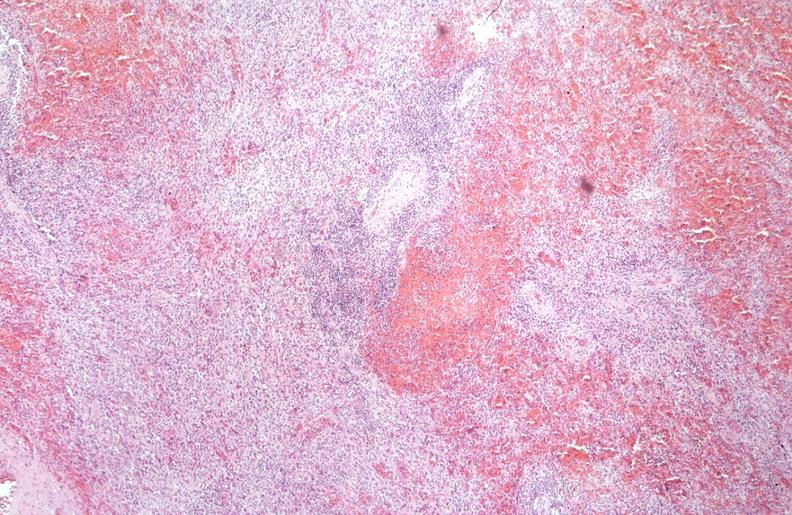what is present?
Answer the question using a single word or phrase. Hematologic 